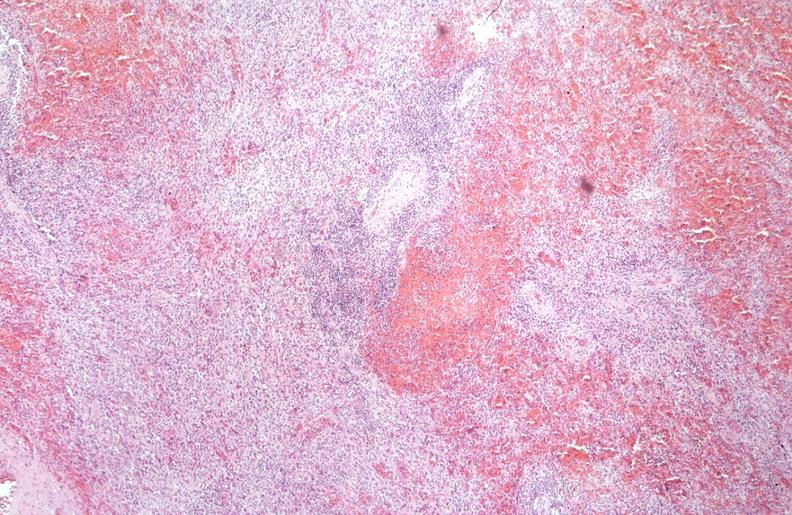what is present?
Answer the question using a single word or phrase. Hematologic 